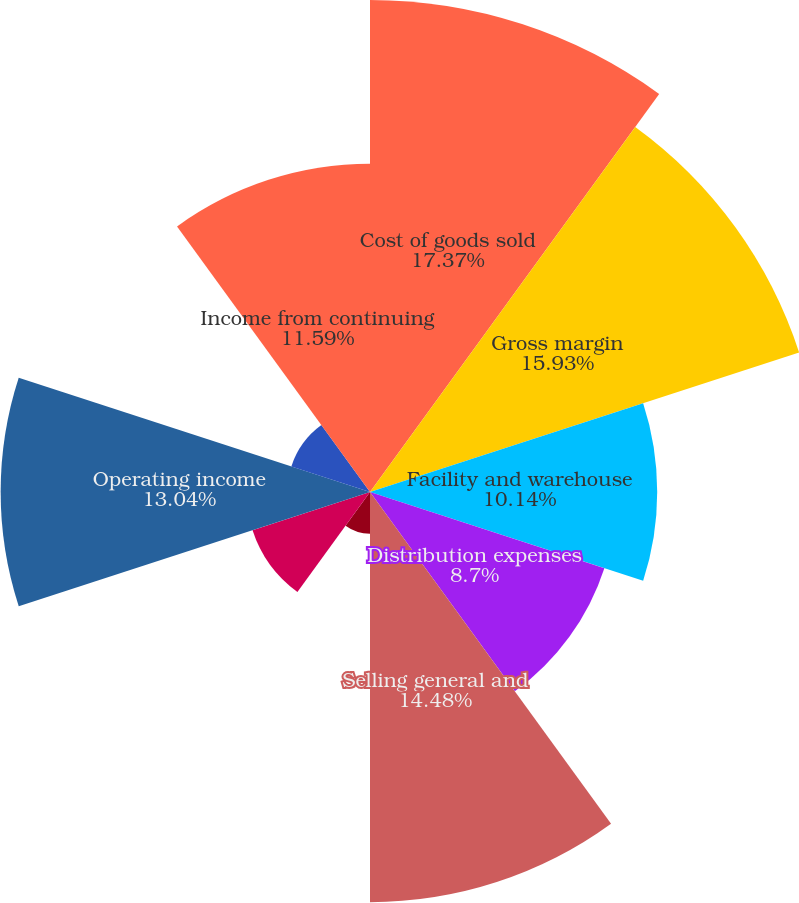Convert chart to OTSL. <chart><loc_0><loc_0><loc_500><loc_500><pie_chart><fcel>Cost of goods sold<fcel>Gross margin<fcel>Facility and warehouse<fcel>Distribution expenses<fcel>Selling general and<fcel>Restructuring expenses<fcel>Depreciation and amortization<fcel>Operating income<fcel>Other expense net<fcel>Income from continuing<nl><fcel>17.37%<fcel>15.93%<fcel>10.14%<fcel>8.7%<fcel>14.48%<fcel>1.47%<fcel>4.36%<fcel>13.04%<fcel>2.92%<fcel>11.59%<nl></chart> 